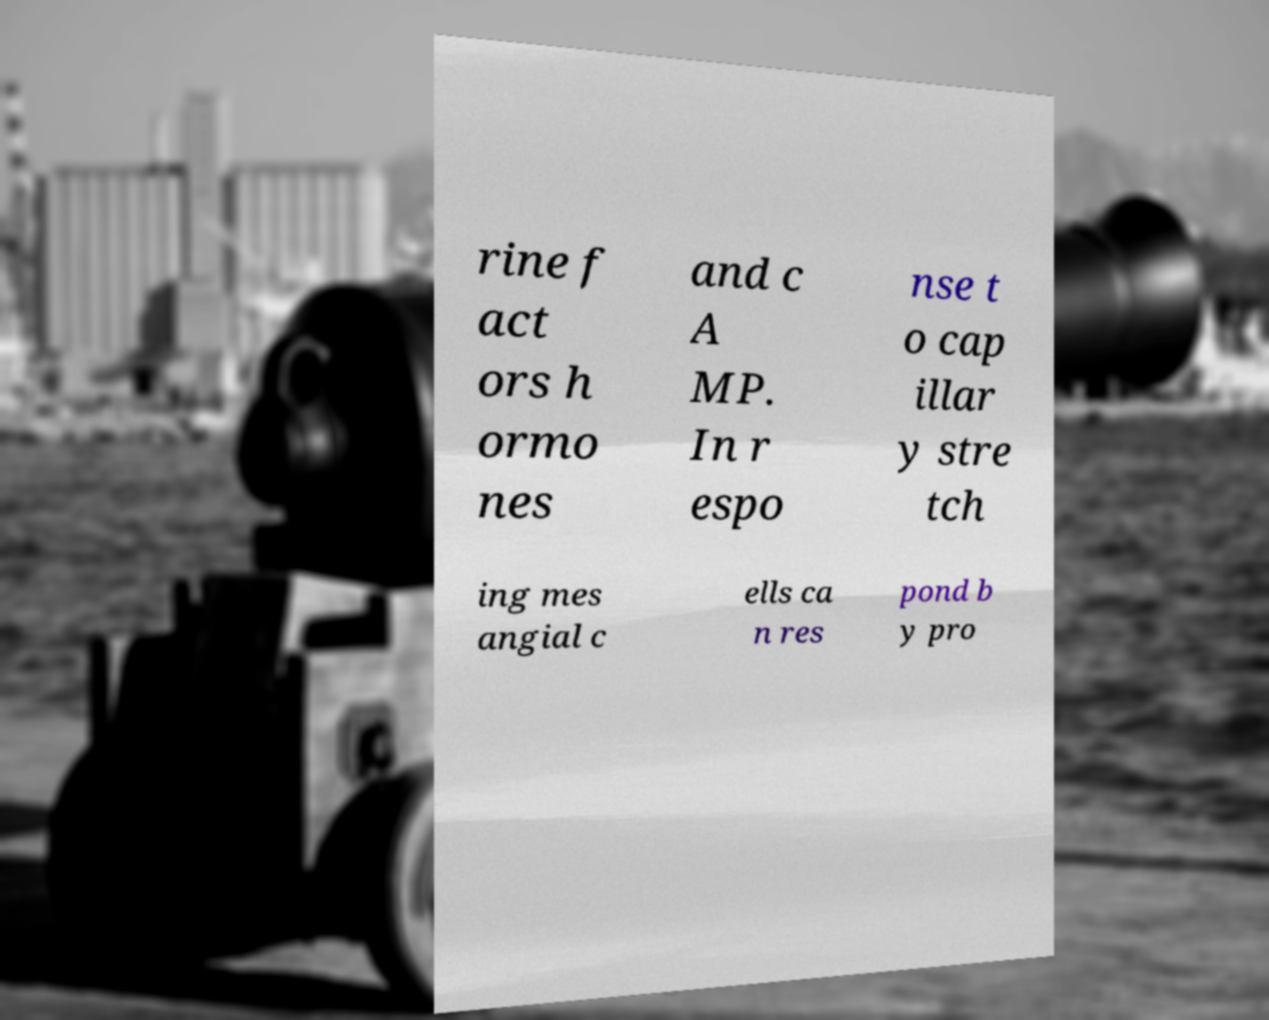Could you extract and type out the text from this image? rine f act ors h ormo nes and c A MP. In r espo nse t o cap illar y stre tch ing mes angial c ells ca n res pond b y pro 